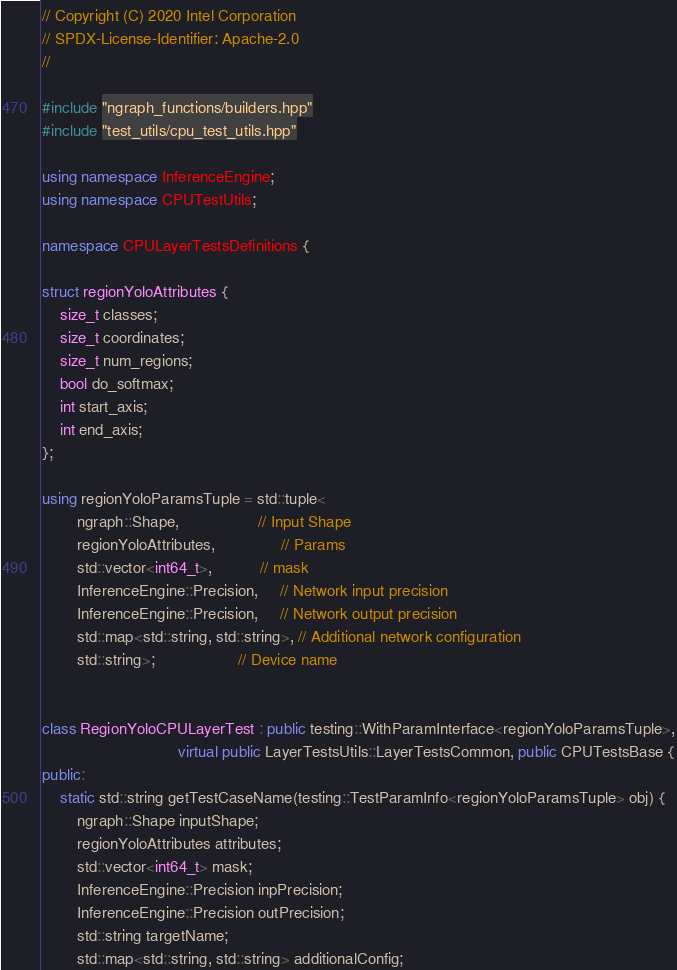Convert code to text. <code><loc_0><loc_0><loc_500><loc_500><_C++_>// Copyright (C) 2020 Intel Corporation
// SPDX-License-Identifier: Apache-2.0
//

#include "ngraph_functions/builders.hpp"
#include "test_utils/cpu_test_utils.hpp"

using namespace InferenceEngine;
using namespace CPUTestUtils;

namespace CPULayerTestsDefinitions {

struct regionYoloAttributes {
    size_t classes;
    size_t coordinates;
    size_t num_regions;
    bool do_softmax;
    int start_axis;
    int end_axis;
};

using regionYoloParamsTuple = std::tuple<
        ngraph::Shape,                  // Input Shape
        regionYoloAttributes,               // Params
        std::vector<int64_t>,           // mask
        InferenceEngine::Precision,     // Network input precision
        InferenceEngine::Precision,     // Network output precision
        std::map<std::string, std::string>, // Additional network configuration
        std::string>;                   // Device name


class RegionYoloCPULayerTest : public testing::WithParamInterface<regionYoloParamsTuple>,
                               virtual public LayerTestsUtils::LayerTestsCommon, public CPUTestsBase {
public:
    static std::string getTestCaseName(testing::TestParamInfo<regionYoloParamsTuple> obj) {
        ngraph::Shape inputShape;
        regionYoloAttributes attributes;
        std::vector<int64_t> mask;
        InferenceEngine::Precision inpPrecision;
        InferenceEngine::Precision outPrecision;
        std::string targetName;
        std::map<std::string, std::string> additionalConfig;
</code> 